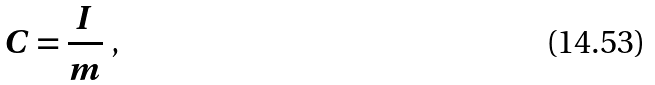<formula> <loc_0><loc_0><loc_500><loc_500>C = \frac { I } { m } \text { ,}</formula> 